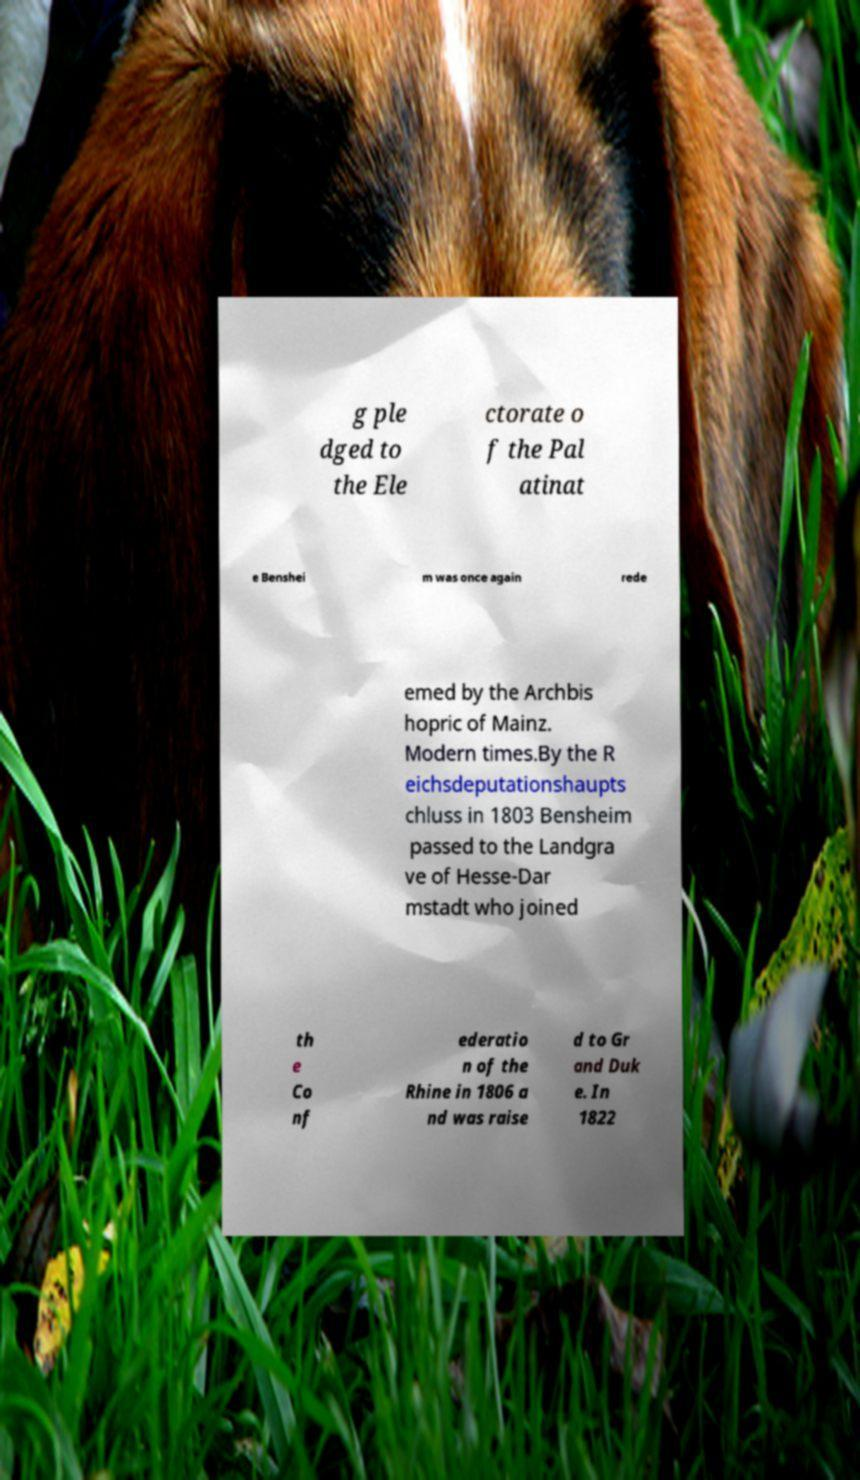Can you accurately transcribe the text from the provided image for me? g ple dged to the Ele ctorate o f the Pal atinat e Benshei m was once again rede emed by the Archbis hopric of Mainz. Modern times.By the R eichsdeputationshaupts chluss in 1803 Bensheim passed to the Landgra ve of Hesse-Dar mstadt who joined th e Co nf ederatio n of the Rhine in 1806 a nd was raise d to Gr and Duk e. In 1822 